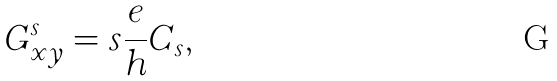Convert formula to latex. <formula><loc_0><loc_0><loc_500><loc_500>G ^ { s } _ { x y } = s \frac { e } { h } C _ { s } ,</formula> 